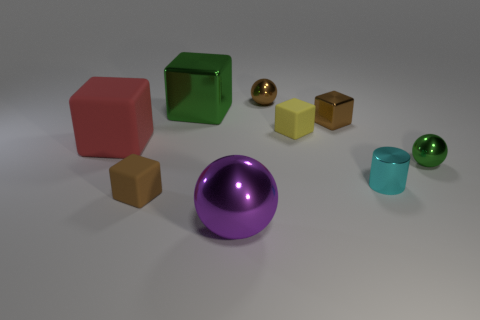Is the material of the tiny cylinder the same as the small ball that is behind the red matte block?
Keep it short and to the point. Yes. There is a purple thing that is made of the same material as the large green block; what is its size?
Give a very brief answer. Large. Are there any brown metallic things of the same shape as the yellow rubber object?
Provide a succinct answer. Yes. How many things are things that are behind the yellow block or big green metal cubes?
Provide a short and direct response. 3. Is the color of the small cube that is in front of the cyan shiny thing the same as the shiny cube that is to the right of the large sphere?
Your answer should be very brief. Yes. What size is the yellow thing?
Ensure brevity in your answer.  Small. How many small things are either cyan metal things or brown blocks?
Ensure brevity in your answer.  3. The cylinder that is the same size as the green shiny ball is what color?
Give a very brief answer. Cyan. How many other things are there of the same shape as the big red rubber thing?
Provide a short and direct response. 4. Is there a small cube made of the same material as the purple sphere?
Offer a very short reply. Yes. 